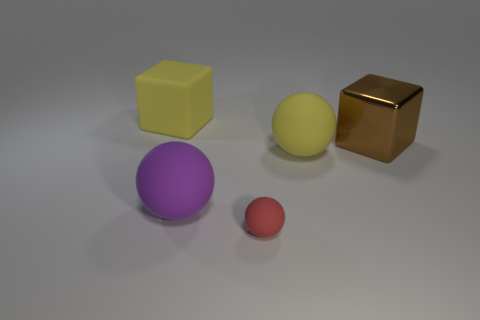Subtract all big rubber balls. How many balls are left? 1 Add 3 tiny red objects. How many objects exist? 8 Subtract all spheres. How many objects are left? 2 Add 2 red objects. How many red objects are left? 3 Add 1 small brown things. How many small brown things exist? 1 Subtract 1 purple balls. How many objects are left? 4 Subtract all brown blocks. Subtract all cyan spheres. How many blocks are left? 1 Subtract all gray metallic balls. Subtract all big metallic blocks. How many objects are left? 4 